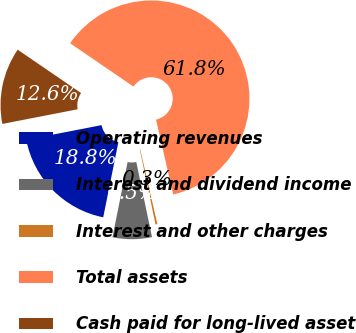Convert chart to OTSL. <chart><loc_0><loc_0><loc_500><loc_500><pie_chart><fcel>Operating revenues<fcel>Interest and dividend income<fcel>Interest and other charges<fcel>Total assets<fcel>Cash paid for long-lived asset<nl><fcel>18.77%<fcel>6.46%<fcel>0.31%<fcel>61.85%<fcel>12.61%<nl></chart> 